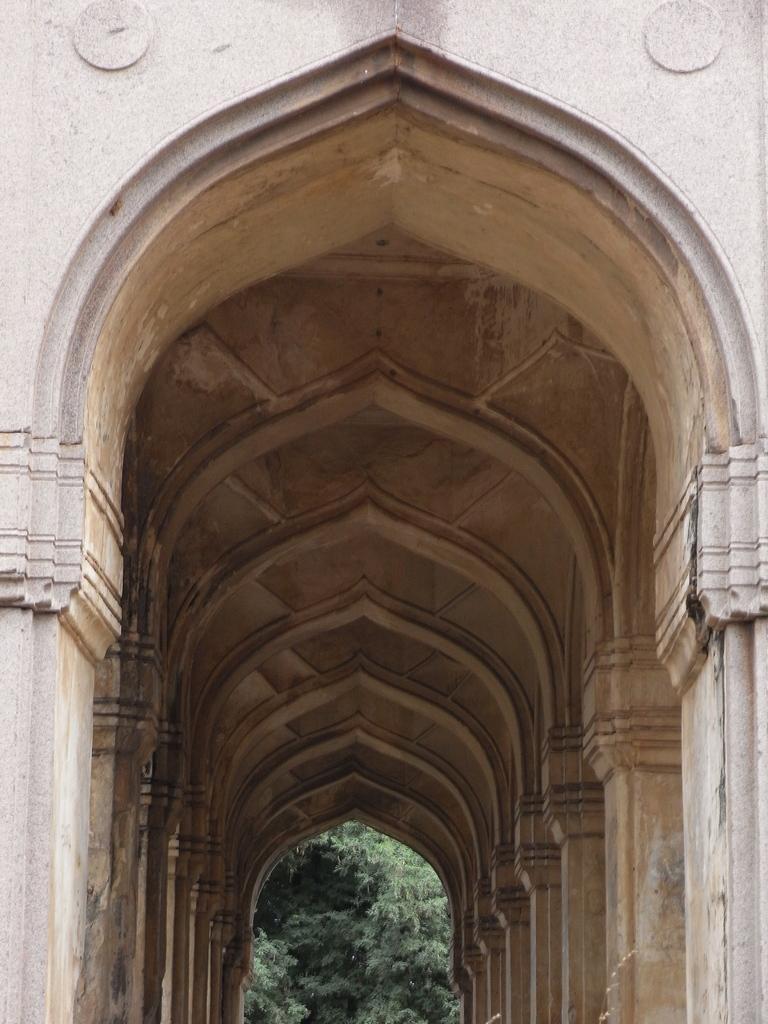Describe this image in one or two sentences. In the center of the image we can see one building, trees, pillars, roof, wall and a few other objects. 